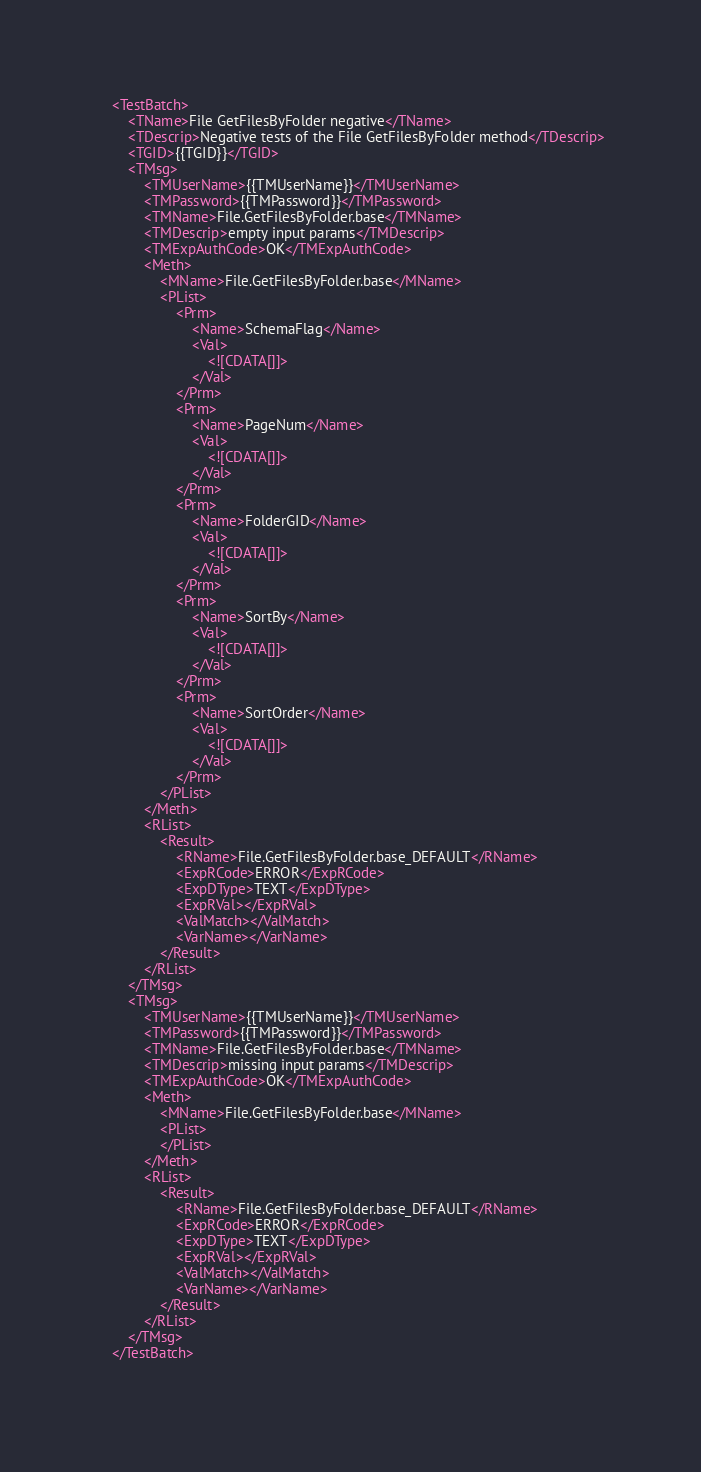Convert code to text. <code><loc_0><loc_0><loc_500><loc_500><_XML_>
	<TestBatch>
		<TName>File GetFilesByFolder negative</TName>
		<TDescrip>Negative tests of the File GetFilesByFolder method</TDescrip>
		<TGID>{{TGID}}</TGID>
		<TMsg>
			<TMUserName>{{TMUserName}}</TMUserName>
			<TMPassword>{{TMPassword}}</TMPassword>
			<TMName>File.GetFilesByFolder.base</TMName>
			<TMDescrip>empty input params</TMDescrip>
			<TMExpAuthCode>OK</TMExpAuthCode>
			<Meth>
				<MName>File.GetFilesByFolder.base</MName>
				<PList>
					<Prm>
						<Name>SchemaFlag</Name>
						<Val>
							<![CDATA[]]>
						</Val>
					</Prm>
					<Prm>
						<Name>PageNum</Name>
						<Val>
							<![CDATA[]]>
						</Val>
					</Prm>
					<Prm>
						<Name>FolderGID</Name>
						<Val>
							<![CDATA[]]>
						</Val>
					</Prm>
					<Prm>
						<Name>SortBy</Name>
						<Val>
							<![CDATA[]]>
						</Val>
					</Prm>
					<Prm>
						<Name>SortOrder</Name>
						<Val>
							<![CDATA[]]>
						</Val>
					</Prm>
				</PList>
			</Meth>
			<RList>
				<Result>
					<RName>File.GetFilesByFolder.base_DEFAULT</RName>
					<ExpRCode>ERROR</ExpRCode>
					<ExpDType>TEXT</ExpDType>
					<ExpRVal></ExpRVal>
					<ValMatch></ValMatch>
					<VarName></VarName>
				</Result>
			</RList>
		</TMsg>
		<TMsg>
			<TMUserName>{{TMUserName}}</TMUserName>
			<TMPassword>{{TMPassword}}</TMPassword>
			<TMName>File.GetFilesByFolder.base</TMName>
			<TMDescrip>missing input params</TMDescrip>
			<TMExpAuthCode>OK</TMExpAuthCode>
			<Meth>
				<MName>File.GetFilesByFolder.base</MName>
				<PList>
				</PList>
			</Meth>
			<RList>
				<Result>
					<RName>File.GetFilesByFolder.base_DEFAULT</RName>
					<ExpRCode>ERROR</ExpRCode>
					<ExpDType>TEXT</ExpDType>
					<ExpRVal></ExpRVal>
					<ValMatch></ValMatch>
					<VarName></VarName>
				</Result>
			</RList>
		</TMsg>
	</TestBatch>
	</code> 